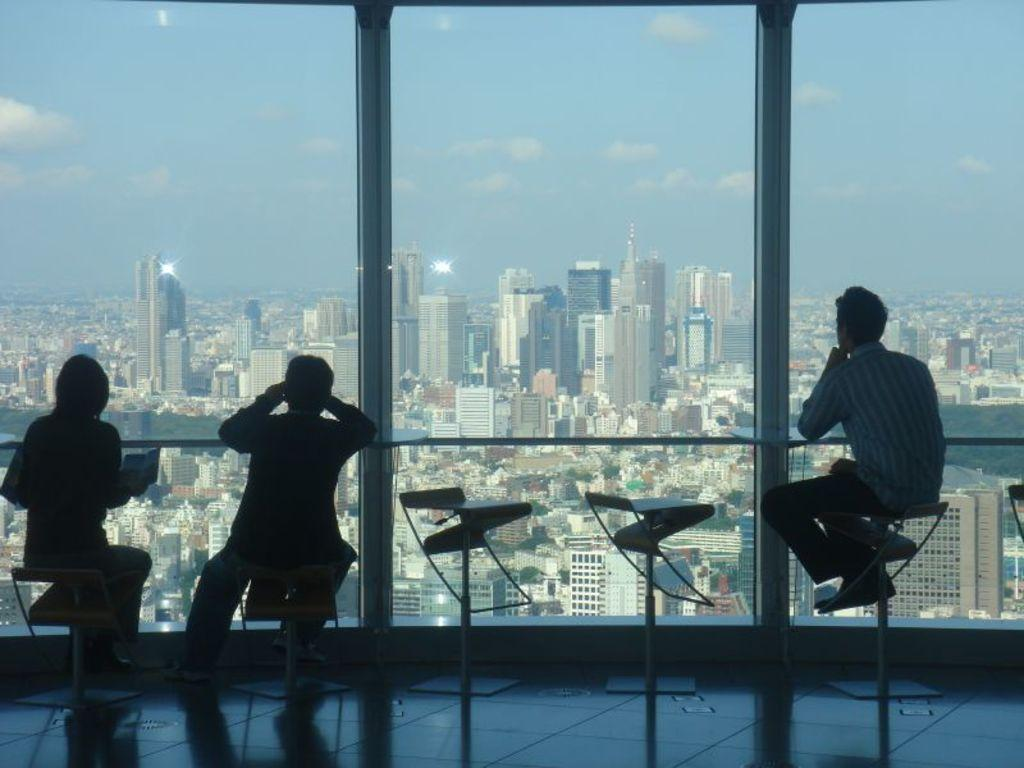What type of furniture is present in the image? There are chairs in the image. What are the chairs being used for? There are persons sitting on the chairs. What can be seen through the glass windows in the image? Buildings, trees, and the sky are visible through the glass windows. What type of stitch is being used to sew the chairs together in the image? There is no mention of stitching or sewing in the image; the chairs are not being assembled or repaired. Can you tell me which part of the building is being driven in the image? There is no vehicle or driving activity present in the image; it features chairs, persons, and glass windows with views of the surroundings. 